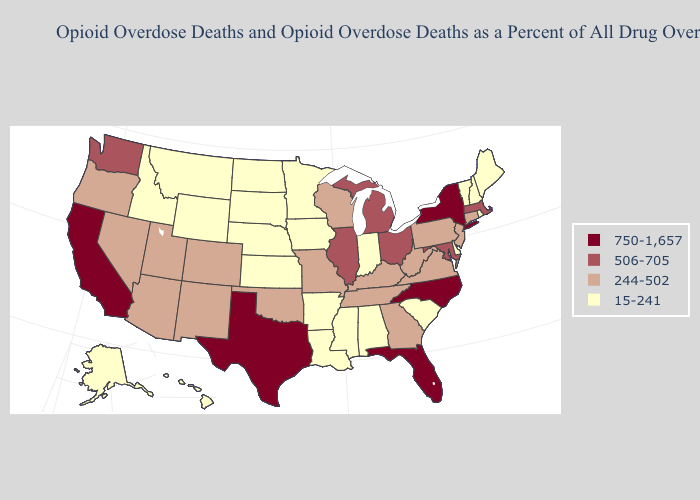Does Minnesota have the lowest value in the USA?
Write a very short answer. Yes. Name the states that have a value in the range 506-705?
Write a very short answer. Illinois, Maryland, Massachusetts, Michigan, Ohio, Washington. Name the states that have a value in the range 15-241?
Keep it brief. Alabama, Alaska, Arkansas, Delaware, Hawaii, Idaho, Indiana, Iowa, Kansas, Louisiana, Maine, Minnesota, Mississippi, Montana, Nebraska, New Hampshire, North Dakota, Rhode Island, South Carolina, South Dakota, Vermont, Wyoming. Does Indiana have the lowest value in the USA?
Quick response, please. Yes. What is the value of North Dakota?
Be succinct. 15-241. Name the states that have a value in the range 15-241?
Answer briefly. Alabama, Alaska, Arkansas, Delaware, Hawaii, Idaho, Indiana, Iowa, Kansas, Louisiana, Maine, Minnesota, Mississippi, Montana, Nebraska, New Hampshire, North Dakota, Rhode Island, South Carolina, South Dakota, Vermont, Wyoming. Which states have the highest value in the USA?
Keep it brief. California, Florida, New York, North Carolina, Texas. Does Illinois have the lowest value in the MidWest?
Answer briefly. No. Is the legend a continuous bar?
Quick response, please. No. What is the highest value in states that border New Jersey?
Give a very brief answer. 750-1,657. What is the value of New Hampshire?
Give a very brief answer. 15-241. What is the lowest value in the MidWest?
Be succinct. 15-241. Name the states that have a value in the range 15-241?
Concise answer only. Alabama, Alaska, Arkansas, Delaware, Hawaii, Idaho, Indiana, Iowa, Kansas, Louisiana, Maine, Minnesota, Mississippi, Montana, Nebraska, New Hampshire, North Dakota, Rhode Island, South Carolina, South Dakota, Vermont, Wyoming. What is the value of New Mexico?
Give a very brief answer. 244-502. What is the value of Nevada?
Keep it brief. 244-502. 